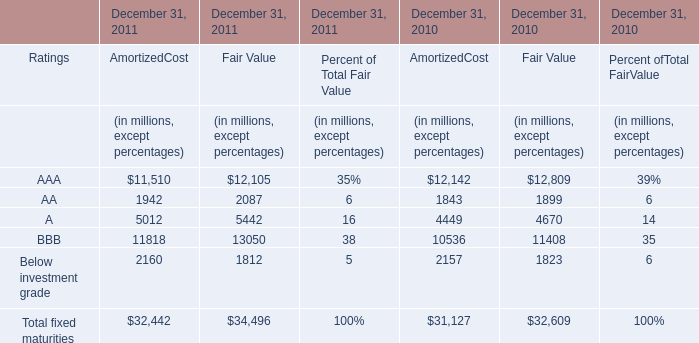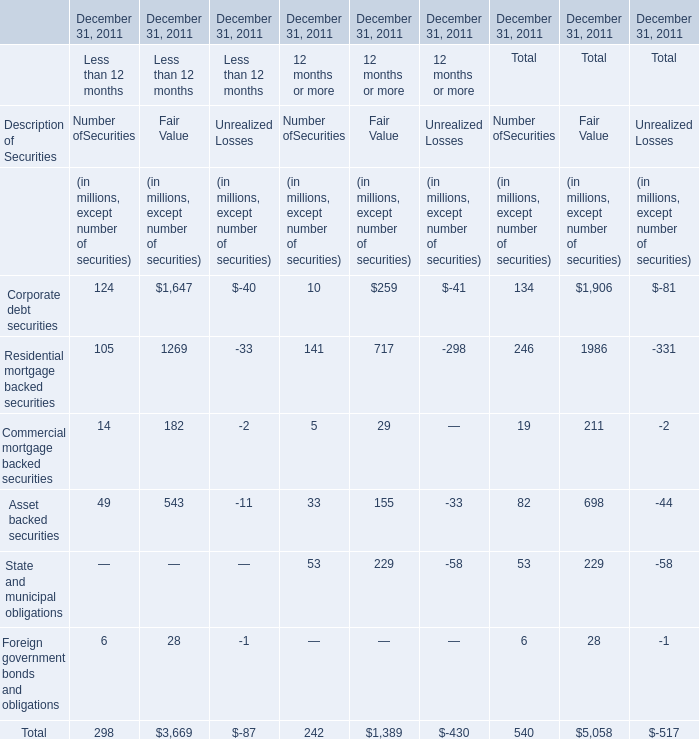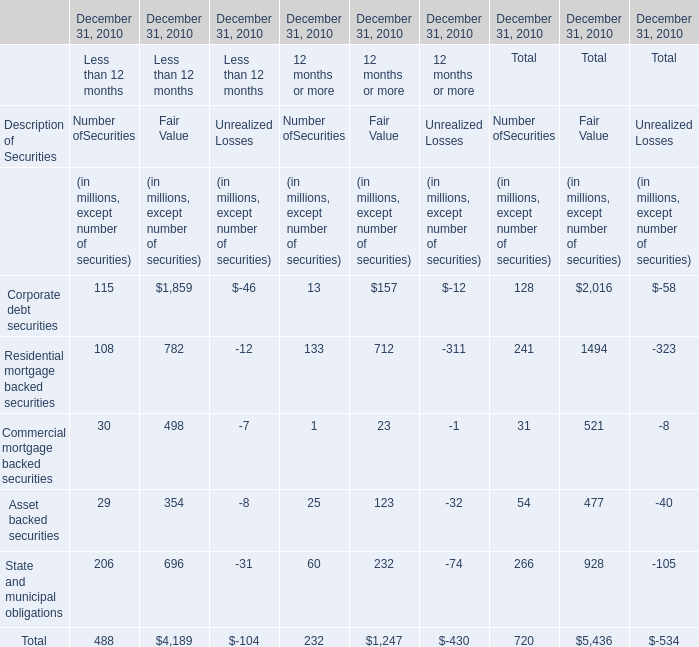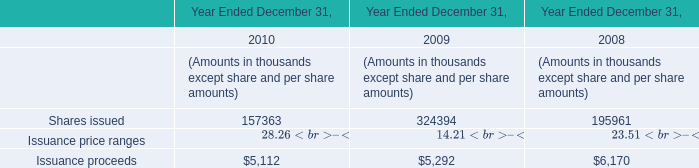If AmortizedCost develops of AA with the same growth rate in 2011, what will it reach in 2012? (in million) 
Computations: (1942 * (1 + ((1942 - 1843) / 1843)))
Answer: 2046.31796. 